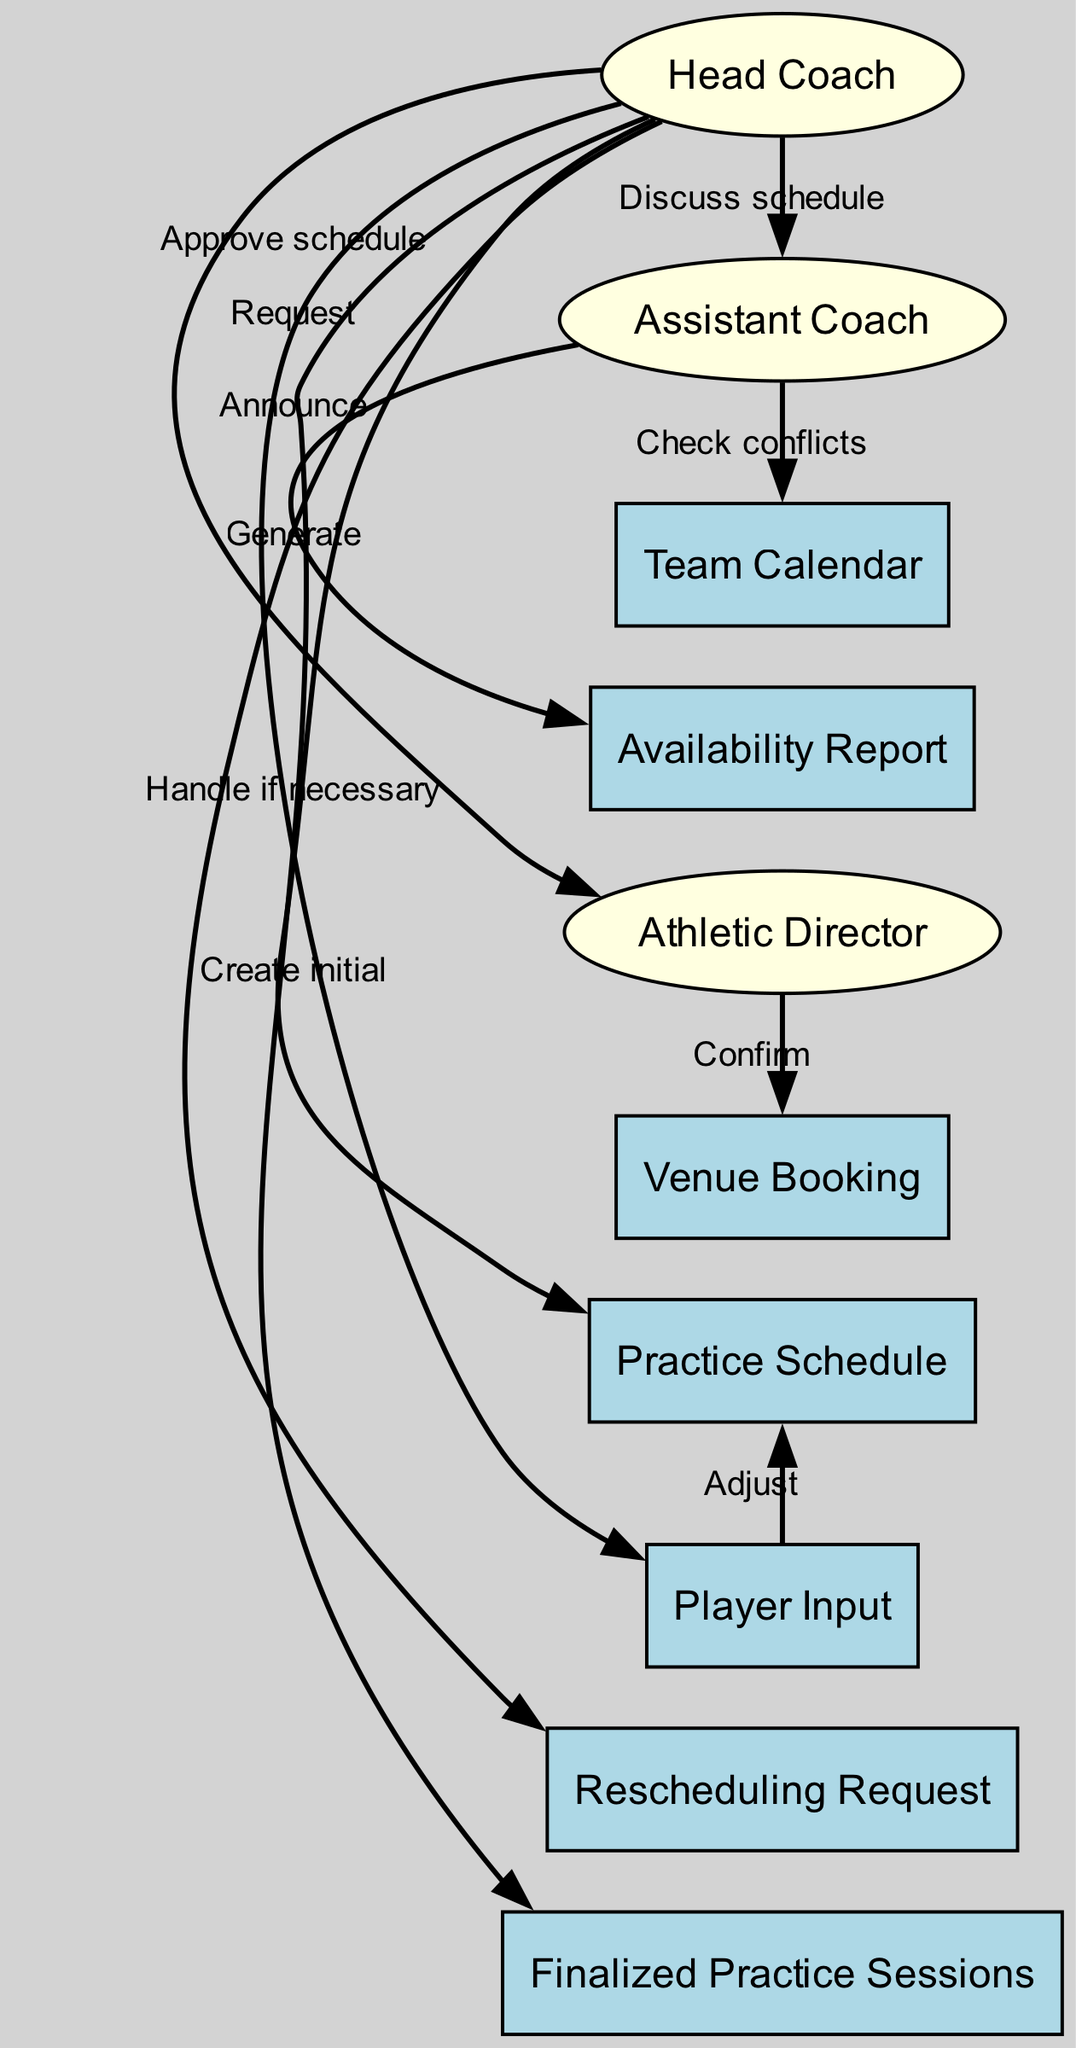What's the total number of actors in the diagram? There are three actors in the diagram: Head Coach, Assistant Coach, and Athletic Director.
Answer: 3 What is the first action the Head Coach takes? The first action the Head Coach takes is to create the initial practice schedule.
Answer: Create initial What does the Assistant Coach do after discussing the schedule with the Head Coach? After discussing the schedule, the Assistant Coach checks for conflicts in the team calendar.
Answer: Check conflicts Which entity is involved in generating the availability report? The Assistant Coach generates the Availability Report.
Answer: Assistant Coach What is the final output of the sequence after the Head Coach announces the finalized practice sessions? The finalized practice sessions are the outcome of the entire sequence of actions.
Answer: Finalized practice sessions Which entity does the Athletic Director confirm? The Athletic Director confirms the Venue Booking.
Answer: Venue Booking What must the Head Coach handle if necessary? The Head Coach must handle the Rescheduling Request if necessary.
Answer: Rescheduling Request How many edges represent actions taken in the sequence? There are nine edges in the diagram which represent the actions taken in the sequence.
Answer: 9 What step occurs after the Player Input adjusts the Practice Schedule? After the Player Input adjusts the Practice Schedule, the Head Coach requests approval from the Athletic Director.
Answer: Request 